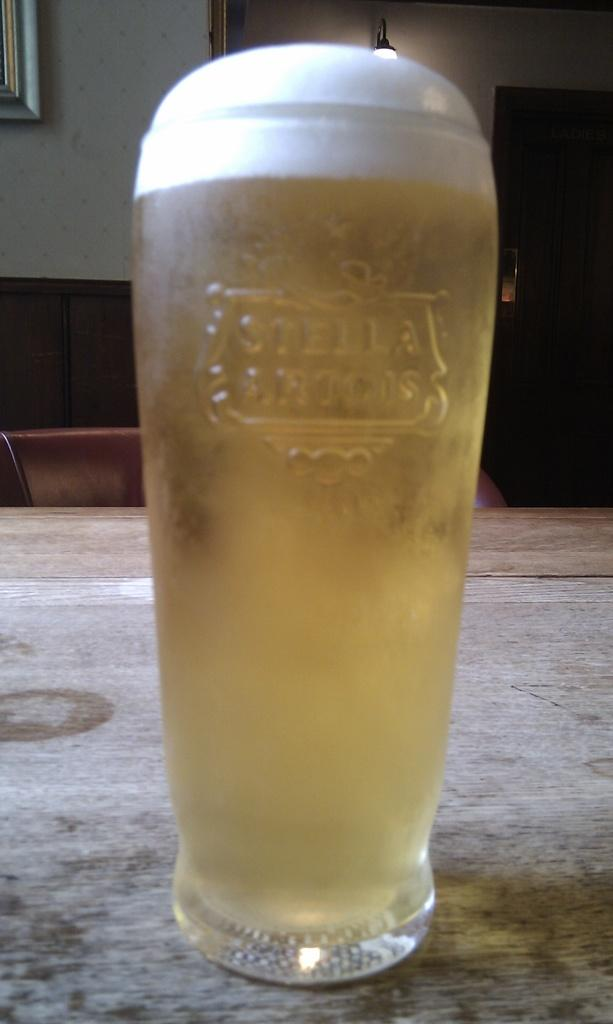<image>
Write a terse but informative summary of the picture. A glass of Stella Artois beer has a perfect head of foam on top of it. 